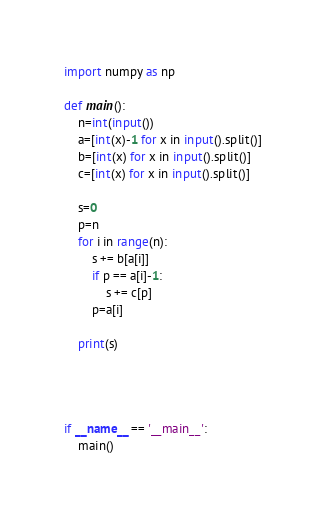Convert code to text. <code><loc_0><loc_0><loc_500><loc_500><_Python_>import numpy as np

def main():
    n=int(input())
    a=[int(x)-1 for x in input().split()]
    b=[int(x) for x in input().split()]
    c=[int(x) for x in input().split()]

    s=0
    p=n
    for i in range(n):
        s += b[a[i]]
        if p == a[i]-1:
            s += c[p]
        p=a[i]

    print(s)




if __name__ == '__main__':
    main()</code> 